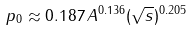<formula> <loc_0><loc_0><loc_500><loc_500>p _ { 0 } \approx 0 . 1 8 7 \, A ^ { 0 . 1 3 6 } ( \sqrt { s } ) ^ { 0 . 2 0 5 }</formula> 